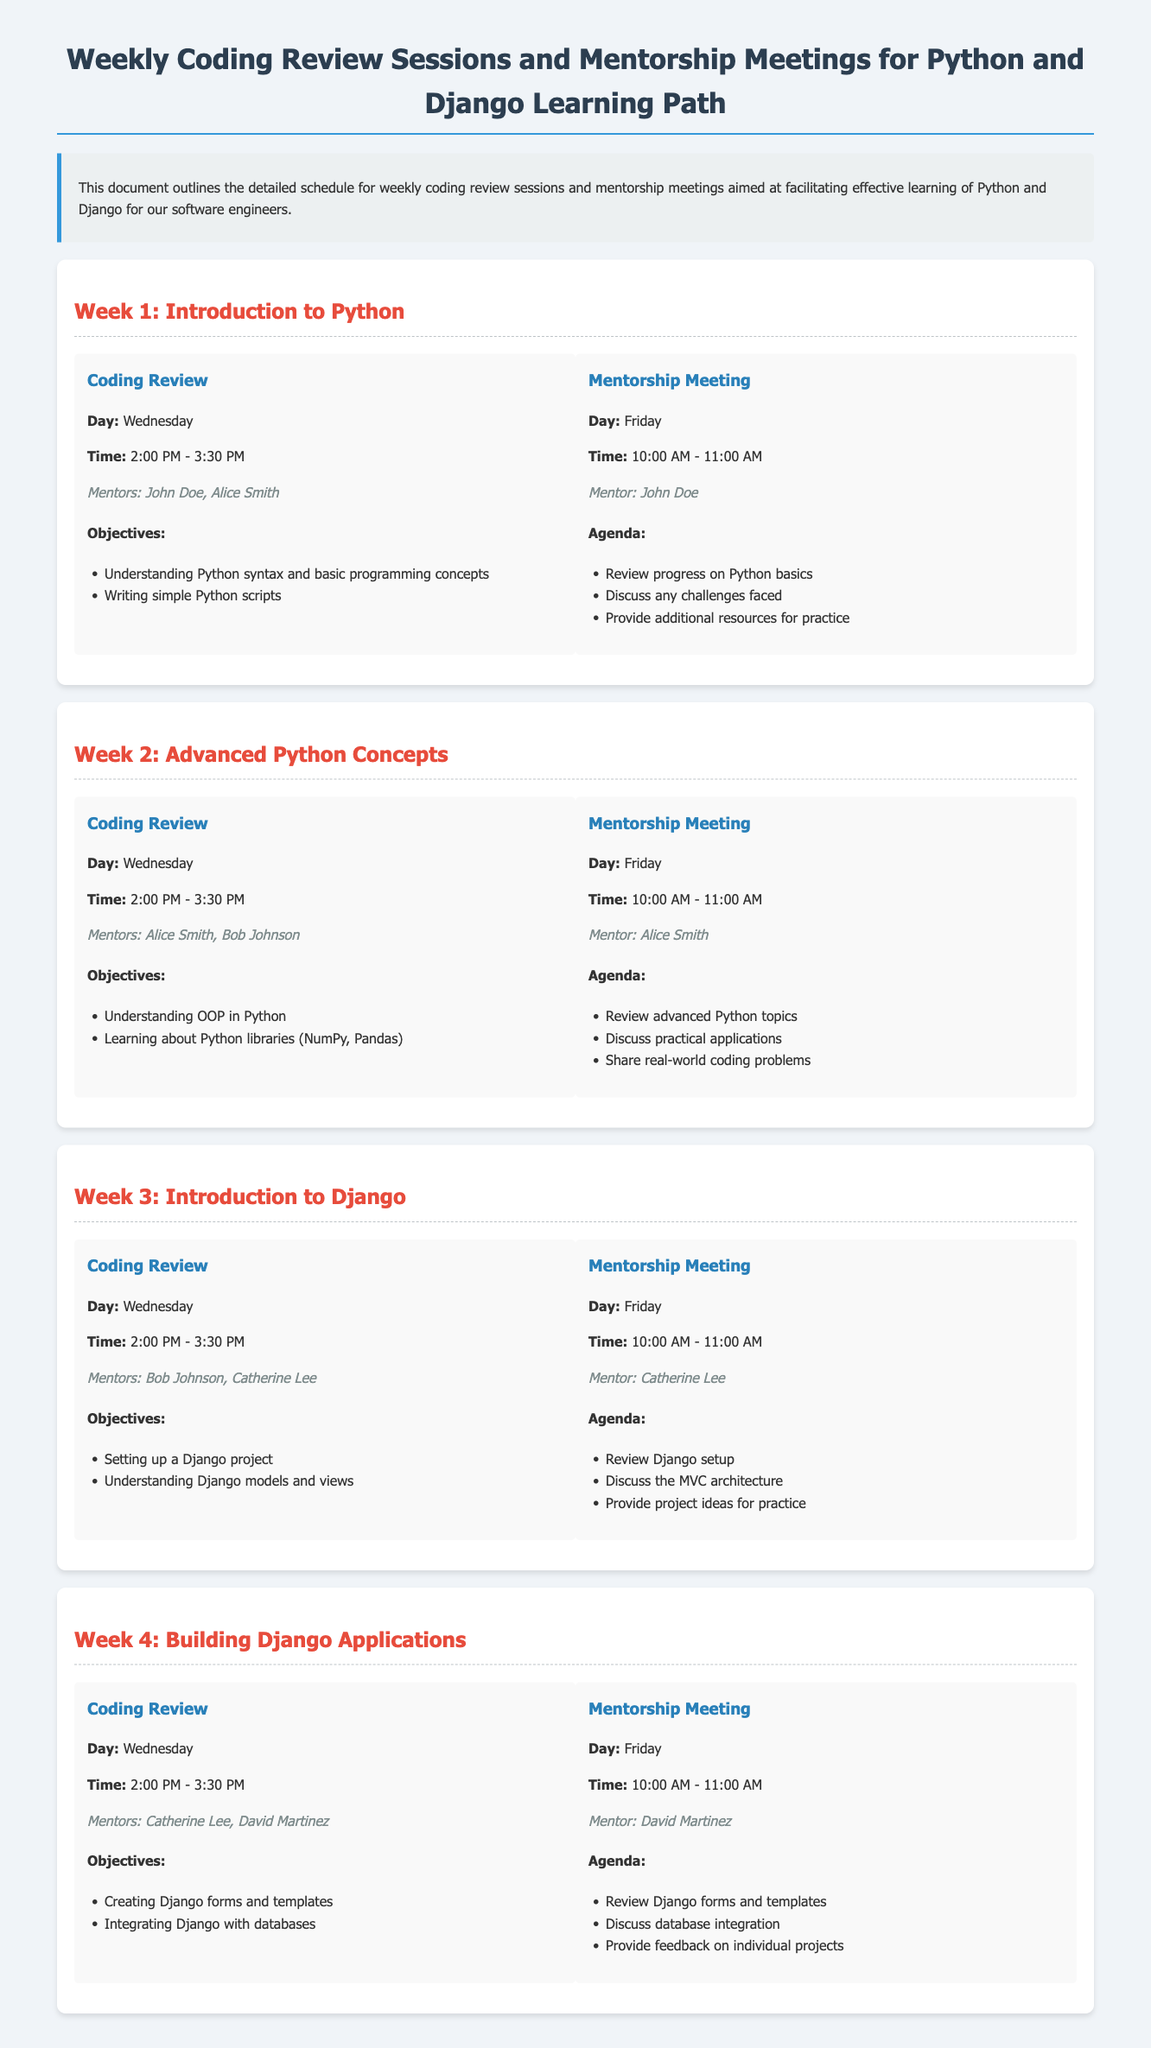What is the title of the document? The title of the document is the heading at the top of the page.
Answer: Weekly Coding Review Sessions and Mentorship Meetings for Python and Django Learning Path Who are the mentors for Week 1 coding review? The mentors for Week 1 coding review are mentioned under the coding review section for Week 1.
Answer: John Doe, Alice Smith What is the time for the mentorship meeting in Week 2? The time is specified in the mentorship meeting section of Week 2.
Answer: 10:00 AM - 11:00 AM How many weeks are covered in the document? The document provides a detailed schedule for multiple weeks, and the number is stated throughout the sections.
Answer: 4 What is the primary objective of Week 3 coding review? The objectives are listed under the coding review session of Week 3, focusing on a specific learning goal.
Answer: Setting up a Django project What is the day of the week for the coding review sessions? The coding review sessions are consistently represented by a specific day mentioned in each week's session.
Answer: Wednesday Who is the mentor for the mentorship meeting in Week 4? The mentor is stated in the mentorship meeting section of Week 4.
Answer: David Martinez What is the primary technology focus of the learning path? The document highlights the technologies being learned as part of the schedule.
Answer: Python and Django 